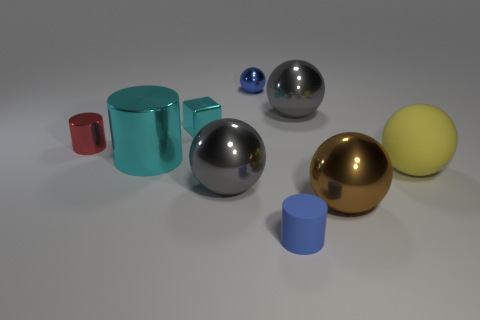Add 1 big green shiny balls. How many objects exist? 10 Subtract all yellow spheres. How many spheres are left? 4 Subtract all small matte cylinders. How many cylinders are left? 2 Subtract all blocks. How many objects are left? 8 Subtract 3 balls. How many balls are left? 2 Subtract all red cylinders. Subtract all large matte balls. How many objects are left? 7 Add 3 blue metal things. How many blue metal things are left? 4 Add 7 large gray shiny things. How many large gray shiny things exist? 9 Subtract 1 blue spheres. How many objects are left? 8 Subtract all gray spheres. Subtract all blue cubes. How many spheres are left? 3 